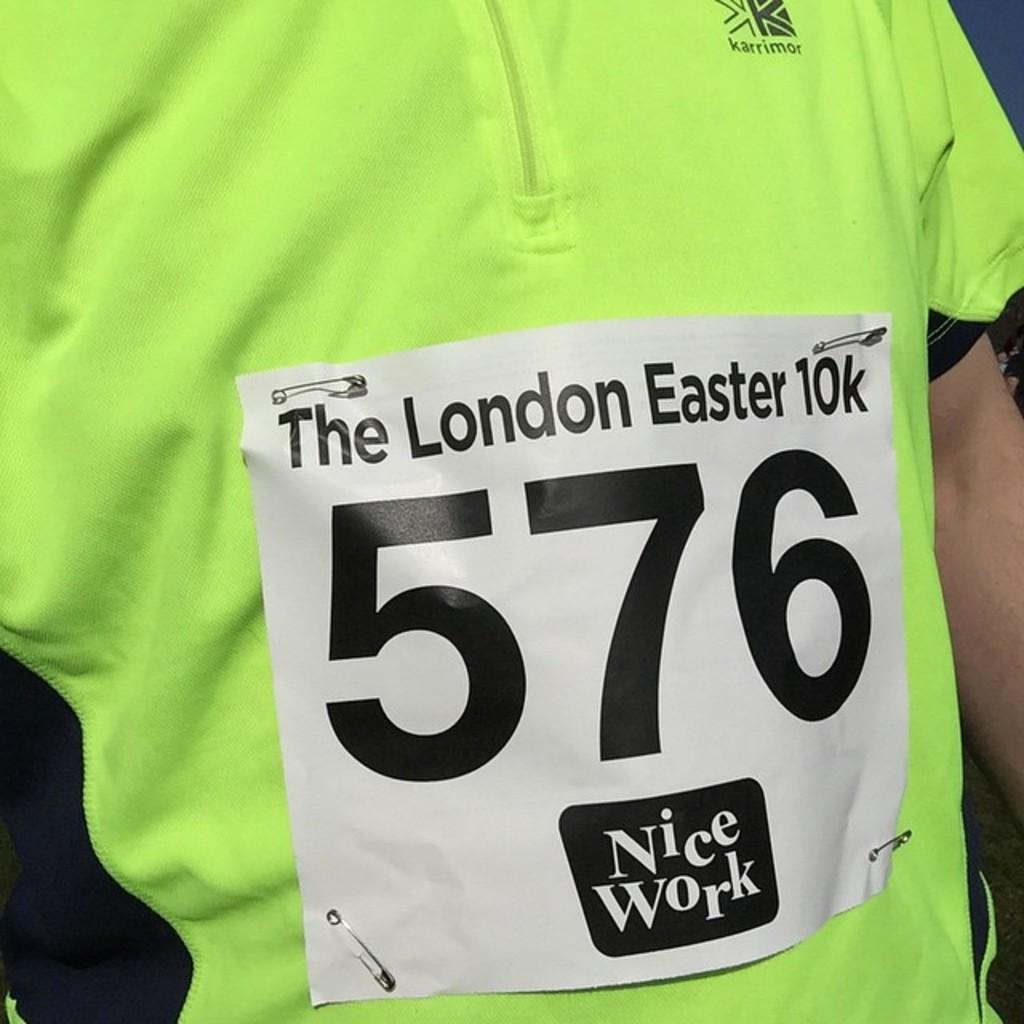<image>
Offer a succinct explanation of the picture presented. A yellow shirt has runner number 576 of The London Easter 10K pinned to it. 